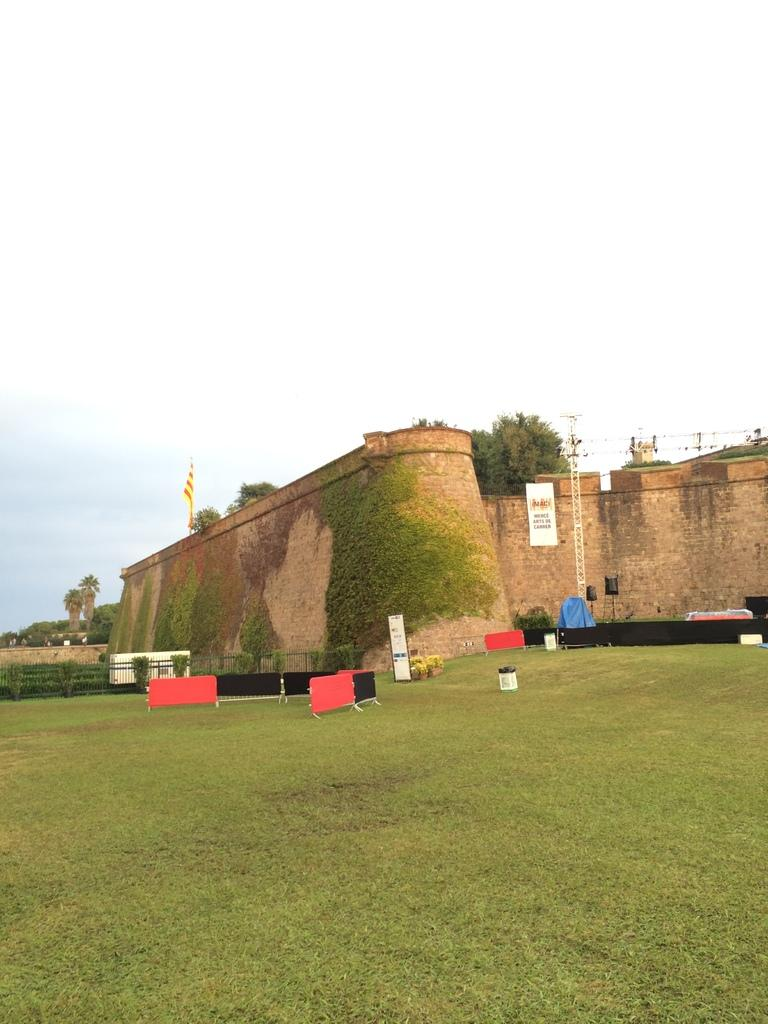What type of structure is visible in the image? There is a fortification in the image. What type of vegetation can be seen in the image? There are trees and grass in the image. What type of barrier is present in the image? There is fencing in the image. What type of surface is used for writing or drawing in the image? There is a white board in the image. What is visible in the background of the image? The sky is visible in the image. What type of coal is being used to fuel the fortification in the image? There is no coal present in the image, and the fortification does not require fuel. 